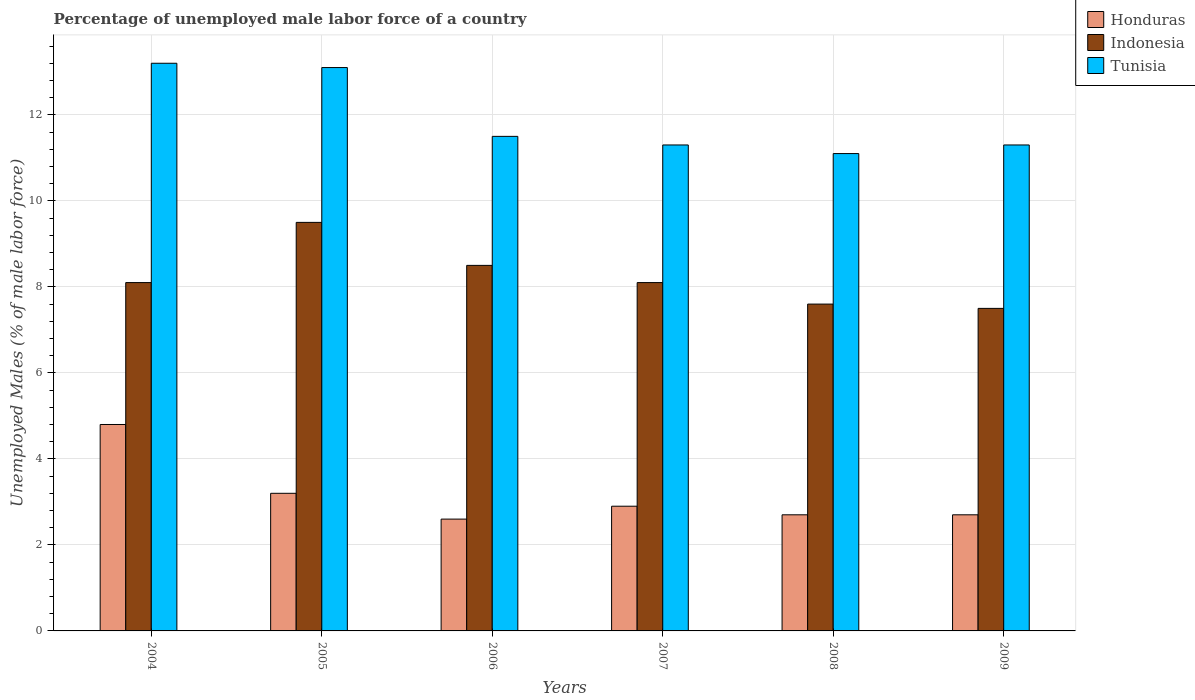Are the number of bars on each tick of the X-axis equal?
Give a very brief answer. Yes. What is the percentage of unemployed male labor force in Tunisia in 2004?
Give a very brief answer. 13.2. Across all years, what is the maximum percentage of unemployed male labor force in Tunisia?
Offer a terse response. 13.2. In which year was the percentage of unemployed male labor force in Indonesia maximum?
Make the answer very short. 2005. In which year was the percentage of unemployed male labor force in Indonesia minimum?
Provide a short and direct response. 2009. What is the total percentage of unemployed male labor force in Indonesia in the graph?
Ensure brevity in your answer.  49.3. What is the difference between the percentage of unemployed male labor force in Indonesia in 2008 and that in 2009?
Offer a terse response. 0.1. What is the difference between the percentage of unemployed male labor force in Honduras in 2007 and the percentage of unemployed male labor force in Tunisia in 2009?
Provide a succinct answer. -8.4. What is the average percentage of unemployed male labor force in Honduras per year?
Your answer should be compact. 3.15. In the year 2006, what is the difference between the percentage of unemployed male labor force in Tunisia and percentage of unemployed male labor force in Indonesia?
Offer a very short reply. 3. In how many years, is the percentage of unemployed male labor force in Honduras greater than 5.2 %?
Provide a short and direct response. 0. What is the ratio of the percentage of unemployed male labor force in Indonesia in 2007 to that in 2009?
Make the answer very short. 1.08. What is the difference between the highest and the second highest percentage of unemployed male labor force in Tunisia?
Ensure brevity in your answer.  0.1. In how many years, is the percentage of unemployed male labor force in Tunisia greater than the average percentage of unemployed male labor force in Tunisia taken over all years?
Give a very brief answer. 2. What does the 1st bar from the left in 2006 represents?
Your answer should be very brief. Honduras. How many bars are there?
Ensure brevity in your answer.  18. How many years are there in the graph?
Offer a very short reply. 6. What is the difference between two consecutive major ticks on the Y-axis?
Keep it short and to the point. 2. Are the values on the major ticks of Y-axis written in scientific E-notation?
Make the answer very short. No. Does the graph contain grids?
Make the answer very short. Yes. What is the title of the graph?
Ensure brevity in your answer.  Percentage of unemployed male labor force of a country. What is the label or title of the X-axis?
Make the answer very short. Years. What is the label or title of the Y-axis?
Keep it short and to the point. Unemployed Males (% of male labor force). What is the Unemployed Males (% of male labor force) of Honduras in 2004?
Offer a very short reply. 4.8. What is the Unemployed Males (% of male labor force) of Indonesia in 2004?
Offer a terse response. 8.1. What is the Unemployed Males (% of male labor force) in Tunisia in 2004?
Make the answer very short. 13.2. What is the Unemployed Males (% of male labor force) in Honduras in 2005?
Your response must be concise. 3.2. What is the Unemployed Males (% of male labor force) of Tunisia in 2005?
Ensure brevity in your answer.  13.1. What is the Unemployed Males (% of male labor force) of Honduras in 2006?
Ensure brevity in your answer.  2.6. What is the Unemployed Males (% of male labor force) of Honduras in 2007?
Provide a succinct answer. 2.9. What is the Unemployed Males (% of male labor force) in Indonesia in 2007?
Offer a very short reply. 8.1. What is the Unemployed Males (% of male labor force) in Tunisia in 2007?
Ensure brevity in your answer.  11.3. What is the Unemployed Males (% of male labor force) of Honduras in 2008?
Keep it short and to the point. 2.7. What is the Unemployed Males (% of male labor force) in Indonesia in 2008?
Your answer should be compact. 7.6. What is the Unemployed Males (% of male labor force) in Tunisia in 2008?
Ensure brevity in your answer.  11.1. What is the Unemployed Males (% of male labor force) in Honduras in 2009?
Ensure brevity in your answer.  2.7. What is the Unemployed Males (% of male labor force) of Indonesia in 2009?
Make the answer very short. 7.5. What is the Unemployed Males (% of male labor force) in Tunisia in 2009?
Ensure brevity in your answer.  11.3. Across all years, what is the maximum Unemployed Males (% of male labor force) in Honduras?
Offer a very short reply. 4.8. Across all years, what is the maximum Unemployed Males (% of male labor force) of Indonesia?
Ensure brevity in your answer.  9.5. Across all years, what is the maximum Unemployed Males (% of male labor force) of Tunisia?
Keep it short and to the point. 13.2. Across all years, what is the minimum Unemployed Males (% of male labor force) in Honduras?
Your answer should be very brief. 2.6. Across all years, what is the minimum Unemployed Males (% of male labor force) in Indonesia?
Ensure brevity in your answer.  7.5. Across all years, what is the minimum Unemployed Males (% of male labor force) in Tunisia?
Ensure brevity in your answer.  11.1. What is the total Unemployed Males (% of male labor force) in Honduras in the graph?
Give a very brief answer. 18.9. What is the total Unemployed Males (% of male labor force) in Indonesia in the graph?
Ensure brevity in your answer.  49.3. What is the total Unemployed Males (% of male labor force) of Tunisia in the graph?
Your answer should be very brief. 71.5. What is the difference between the Unemployed Males (% of male labor force) of Indonesia in 2004 and that in 2005?
Your answer should be very brief. -1.4. What is the difference between the Unemployed Males (% of male labor force) in Tunisia in 2004 and that in 2005?
Give a very brief answer. 0.1. What is the difference between the Unemployed Males (% of male labor force) of Honduras in 2004 and that in 2006?
Make the answer very short. 2.2. What is the difference between the Unemployed Males (% of male labor force) of Indonesia in 2004 and that in 2007?
Make the answer very short. 0. What is the difference between the Unemployed Males (% of male labor force) of Tunisia in 2004 and that in 2009?
Your answer should be very brief. 1.9. What is the difference between the Unemployed Males (% of male labor force) of Indonesia in 2005 and that in 2006?
Make the answer very short. 1. What is the difference between the Unemployed Males (% of male labor force) in Tunisia in 2005 and that in 2006?
Ensure brevity in your answer.  1.6. What is the difference between the Unemployed Males (% of male labor force) of Honduras in 2005 and that in 2007?
Make the answer very short. 0.3. What is the difference between the Unemployed Males (% of male labor force) of Indonesia in 2005 and that in 2007?
Offer a very short reply. 1.4. What is the difference between the Unemployed Males (% of male labor force) in Tunisia in 2005 and that in 2008?
Offer a terse response. 2. What is the difference between the Unemployed Males (% of male labor force) in Indonesia in 2005 and that in 2009?
Keep it short and to the point. 2. What is the difference between the Unemployed Males (% of male labor force) of Honduras in 2006 and that in 2007?
Offer a very short reply. -0.3. What is the difference between the Unemployed Males (% of male labor force) in Honduras in 2006 and that in 2008?
Your response must be concise. -0.1. What is the difference between the Unemployed Males (% of male labor force) in Indonesia in 2006 and that in 2009?
Your answer should be compact. 1. What is the difference between the Unemployed Males (% of male labor force) of Indonesia in 2007 and that in 2008?
Make the answer very short. 0.5. What is the difference between the Unemployed Males (% of male labor force) of Honduras in 2007 and that in 2009?
Your response must be concise. 0.2. What is the difference between the Unemployed Males (% of male labor force) of Indonesia in 2007 and that in 2009?
Provide a succinct answer. 0.6. What is the difference between the Unemployed Males (% of male labor force) in Tunisia in 2007 and that in 2009?
Give a very brief answer. 0. What is the difference between the Unemployed Males (% of male labor force) in Indonesia in 2008 and that in 2009?
Your answer should be very brief. 0.1. What is the difference between the Unemployed Males (% of male labor force) of Honduras in 2004 and the Unemployed Males (% of male labor force) of Tunisia in 2006?
Give a very brief answer. -6.7. What is the difference between the Unemployed Males (% of male labor force) in Indonesia in 2004 and the Unemployed Males (% of male labor force) in Tunisia in 2006?
Your answer should be compact. -3.4. What is the difference between the Unemployed Males (% of male labor force) of Honduras in 2004 and the Unemployed Males (% of male labor force) of Tunisia in 2007?
Offer a very short reply. -6.5. What is the difference between the Unemployed Males (% of male labor force) in Indonesia in 2004 and the Unemployed Males (% of male labor force) in Tunisia in 2007?
Provide a succinct answer. -3.2. What is the difference between the Unemployed Males (% of male labor force) in Honduras in 2004 and the Unemployed Males (% of male labor force) in Indonesia in 2008?
Provide a succinct answer. -2.8. What is the difference between the Unemployed Males (% of male labor force) in Indonesia in 2004 and the Unemployed Males (% of male labor force) in Tunisia in 2008?
Your answer should be very brief. -3. What is the difference between the Unemployed Males (% of male labor force) in Honduras in 2004 and the Unemployed Males (% of male labor force) in Indonesia in 2009?
Offer a very short reply. -2.7. What is the difference between the Unemployed Males (% of male labor force) of Indonesia in 2004 and the Unemployed Males (% of male labor force) of Tunisia in 2009?
Offer a very short reply. -3.2. What is the difference between the Unemployed Males (% of male labor force) of Indonesia in 2005 and the Unemployed Males (% of male labor force) of Tunisia in 2006?
Provide a succinct answer. -2. What is the difference between the Unemployed Males (% of male labor force) in Honduras in 2005 and the Unemployed Males (% of male labor force) in Indonesia in 2007?
Provide a short and direct response. -4.9. What is the difference between the Unemployed Males (% of male labor force) of Indonesia in 2005 and the Unemployed Males (% of male labor force) of Tunisia in 2007?
Your answer should be compact. -1.8. What is the difference between the Unemployed Males (% of male labor force) of Honduras in 2005 and the Unemployed Males (% of male labor force) of Indonesia in 2009?
Make the answer very short. -4.3. What is the difference between the Unemployed Males (% of male labor force) in Indonesia in 2005 and the Unemployed Males (% of male labor force) in Tunisia in 2009?
Your response must be concise. -1.8. What is the difference between the Unemployed Males (% of male labor force) in Honduras in 2006 and the Unemployed Males (% of male labor force) in Indonesia in 2007?
Your response must be concise. -5.5. What is the difference between the Unemployed Males (% of male labor force) of Honduras in 2006 and the Unemployed Males (% of male labor force) of Tunisia in 2009?
Offer a very short reply. -8.7. What is the difference between the Unemployed Males (% of male labor force) of Indonesia in 2006 and the Unemployed Males (% of male labor force) of Tunisia in 2009?
Make the answer very short. -2.8. What is the difference between the Unemployed Males (% of male labor force) of Honduras in 2007 and the Unemployed Males (% of male labor force) of Indonesia in 2008?
Ensure brevity in your answer.  -4.7. What is the difference between the Unemployed Males (% of male labor force) in Honduras in 2007 and the Unemployed Males (% of male labor force) in Tunisia in 2008?
Provide a succinct answer. -8.2. What is the difference between the Unemployed Males (% of male labor force) of Honduras in 2007 and the Unemployed Males (% of male labor force) of Tunisia in 2009?
Your response must be concise. -8.4. What is the difference between the Unemployed Males (% of male labor force) in Indonesia in 2007 and the Unemployed Males (% of male labor force) in Tunisia in 2009?
Provide a succinct answer. -3.2. What is the difference between the Unemployed Males (% of male labor force) in Honduras in 2008 and the Unemployed Males (% of male labor force) in Indonesia in 2009?
Make the answer very short. -4.8. What is the difference between the Unemployed Males (% of male labor force) in Honduras in 2008 and the Unemployed Males (% of male labor force) in Tunisia in 2009?
Offer a terse response. -8.6. What is the average Unemployed Males (% of male labor force) of Honduras per year?
Your answer should be compact. 3.15. What is the average Unemployed Males (% of male labor force) of Indonesia per year?
Your answer should be compact. 8.22. What is the average Unemployed Males (% of male labor force) in Tunisia per year?
Offer a very short reply. 11.92. In the year 2004, what is the difference between the Unemployed Males (% of male labor force) in Honduras and Unemployed Males (% of male labor force) in Indonesia?
Provide a short and direct response. -3.3. In the year 2006, what is the difference between the Unemployed Males (% of male labor force) in Honduras and Unemployed Males (% of male labor force) in Indonesia?
Offer a terse response. -5.9. In the year 2006, what is the difference between the Unemployed Males (% of male labor force) in Honduras and Unemployed Males (% of male labor force) in Tunisia?
Your answer should be compact. -8.9. In the year 2008, what is the difference between the Unemployed Males (% of male labor force) of Honduras and Unemployed Males (% of male labor force) of Indonesia?
Offer a terse response. -4.9. In the year 2008, what is the difference between the Unemployed Males (% of male labor force) of Honduras and Unemployed Males (% of male labor force) of Tunisia?
Make the answer very short. -8.4. In the year 2008, what is the difference between the Unemployed Males (% of male labor force) in Indonesia and Unemployed Males (% of male labor force) in Tunisia?
Ensure brevity in your answer.  -3.5. In the year 2009, what is the difference between the Unemployed Males (% of male labor force) in Honduras and Unemployed Males (% of male labor force) in Indonesia?
Make the answer very short. -4.8. In the year 2009, what is the difference between the Unemployed Males (% of male labor force) in Indonesia and Unemployed Males (% of male labor force) in Tunisia?
Your response must be concise. -3.8. What is the ratio of the Unemployed Males (% of male labor force) in Honduras in 2004 to that in 2005?
Keep it short and to the point. 1.5. What is the ratio of the Unemployed Males (% of male labor force) of Indonesia in 2004 to that in 2005?
Your response must be concise. 0.85. What is the ratio of the Unemployed Males (% of male labor force) in Tunisia in 2004 to that in 2005?
Keep it short and to the point. 1.01. What is the ratio of the Unemployed Males (% of male labor force) of Honduras in 2004 to that in 2006?
Give a very brief answer. 1.85. What is the ratio of the Unemployed Males (% of male labor force) of Indonesia in 2004 to that in 2006?
Give a very brief answer. 0.95. What is the ratio of the Unemployed Males (% of male labor force) in Tunisia in 2004 to that in 2006?
Your answer should be compact. 1.15. What is the ratio of the Unemployed Males (% of male labor force) in Honduras in 2004 to that in 2007?
Keep it short and to the point. 1.66. What is the ratio of the Unemployed Males (% of male labor force) of Indonesia in 2004 to that in 2007?
Your response must be concise. 1. What is the ratio of the Unemployed Males (% of male labor force) of Tunisia in 2004 to that in 2007?
Your answer should be compact. 1.17. What is the ratio of the Unemployed Males (% of male labor force) of Honduras in 2004 to that in 2008?
Provide a short and direct response. 1.78. What is the ratio of the Unemployed Males (% of male labor force) in Indonesia in 2004 to that in 2008?
Keep it short and to the point. 1.07. What is the ratio of the Unemployed Males (% of male labor force) of Tunisia in 2004 to that in 2008?
Provide a short and direct response. 1.19. What is the ratio of the Unemployed Males (% of male labor force) of Honduras in 2004 to that in 2009?
Provide a short and direct response. 1.78. What is the ratio of the Unemployed Males (% of male labor force) in Tunisia in 2004 to that in 2009?
Provide a short and direct response. 1.17. What is the ratio of the Unemployed Males (% of male labor force) in Honduras in 2005 to that in 2006?
Make the answer very short. 1.23. What is the ratio of the Unemployed Males (% of male labor force) of Indonesia in 2005 to that in 2006?
Make the answer very short. 1.12. What is the ratio of the Unemployed Males (% of male labor force) of Tunisia in 2005 to that in 2006?
Your answer should be very brief. 1.14. What is the ratio of the Unemployed Males (% of male labor force) in Honduras in 2005 to that in 2007?
Give a very brief answer. 1.1. What is the ratio of the Unemployed Males (% of male labor force) of Indonesia in 2005 to that in 2007?
Keep it short and to the point. 1.17. What is the ratio of the Unemployed Males (% of male labor force) in Tunisia in 2005 to that in 2007?
Your answer should be very brief. 1.16. What is the ratio of the Unemployed Males (% of male labor force) in Honduras in 2005 to that in 2008?
Keep it short and to the point. 1.19. What is the ratio of the Unemployed Males (% of male labor force) in Tunisia in 2005 to that in 2008?
Keep it short and to the point. 1.18. What is the ratio of the Unemployed Males (% of male labor force) in Honduras in 2005 to that in 2009?
Your answer should be compact. 1.19. What is the ratio of the Unemployed Males (% of male labor force) in Indonesia in 2005 to that in 2009?
Provide a succinct answer. 1.27. What is the ratio of the Unemployed Males (% of male labor force) of Tunisia in 2005 to that in 2009?
Make the answer very short. 1.16. What is the ratio of the Unemployed Males (% of male labor force) of Honduras in 2006 to that in 2007?
Keep it short and to the point. 0.9. What is the ratio of the Unemployed Males (% of male labor force) in Indonesia in 2006 to that in 2007?
Offer a terse response. 1.05. What is the ratio of the Unemployed Males (% of male labor force) in Tunisia in 2006 to that in 2007?
Your answer should be very brief. 1.02. What is the ratio of the Unemployed Males (% of male labor force) of Honduras in 2006 to that in 2008?
Provide a short and direct response. 0.96. What is the ratio of the Unemployed Males (% of male labor force) of Indonesia in 2006 to that in 2008?
Offer a very short reply. 1.12. What is the ratio of the Unemployed Males (% of male labor force) in Tunisia in 2006 to that in 2008?
Keep it short and to the point. 1.04. What is the ratio of the Unemployed Males (% of male labor force) in Honduras in 2006 to that in 2009?
Make the answer very short. 0.96. What is the ratio of the Unemployed Males (% of male labor force) in Indonesia in 2006 to that in 2009?
Ensure brevity in your answer.  1.13. What is the ratio of the Unemployed Males (% of male labor force) of Tunisia in 2006 to that in 2009?
Ensure brevity in your answer.  1.02. What is the ratio of the Unemployed Males (% of male labor force) of Honduras in 2007 to that in 2008?
Provide a short and direct response. 1.07. What is the ratio of the Unemployed Males (% of male labor force) in Indonesia in 2007 to that in 2008?
Your response must be concise. 1.07. What is the ratio of the Unemployed Males (% of male labor force) in Tunisia in 2007 to that in 2008?
Provide a short and direct response. 1.02. What is the ratio of the Unemployed Males (% of male labor force) of Honduras in 2007 to that in 2009?
Ensure brevity in your answer.  1.07. What is the ratio of the Unemployed Males (% of male labor force) of Tunisia in 2007 to that in 2009?
Give a very brief answer. 1. What is the ratio of the Unemployed Males (% of male labor force) of Indonesia in 2008 to that in 2009?
Provide a succinct answer. 1.01. What is the ratio of the Unemployed Males (% of male labor force) in Tunisia in 2008 to that in 2009?
Make the answer very short. 0.98. What is the difference between the highest and the second highest Unemployed Males (% of male labor force) of Tunisia?
Keep it short and to the point. 0.1. What is the difference between the highest and the lowest Unemployed Males (% of male labor force) of Honduras?
Provide a short and direct response. 2.2. What is the difference between the highest and the lowest Unemployed Males (% of male labor force) of Tunisia?
Make the answer very short. 2.1. 